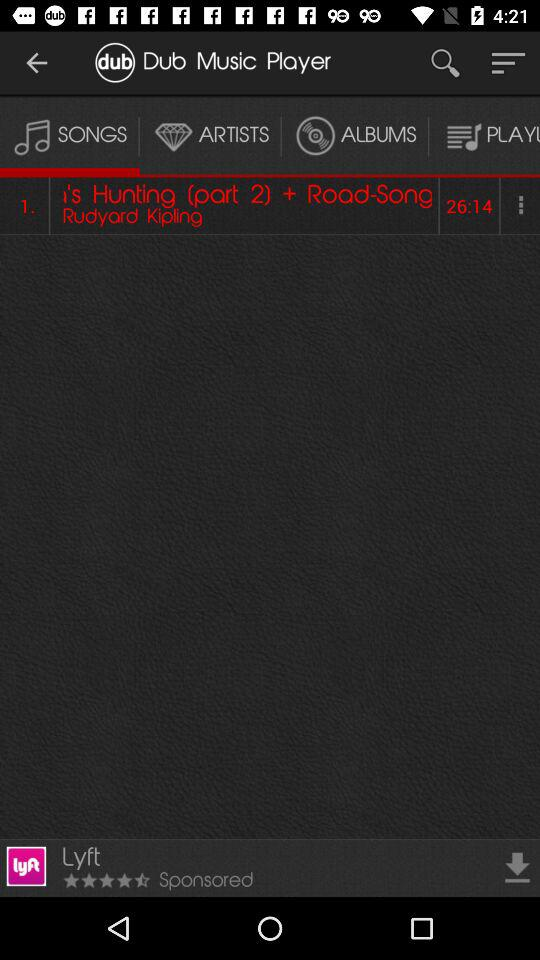What is the duration of the song? The duration is 26 minutes 14 seconds. 